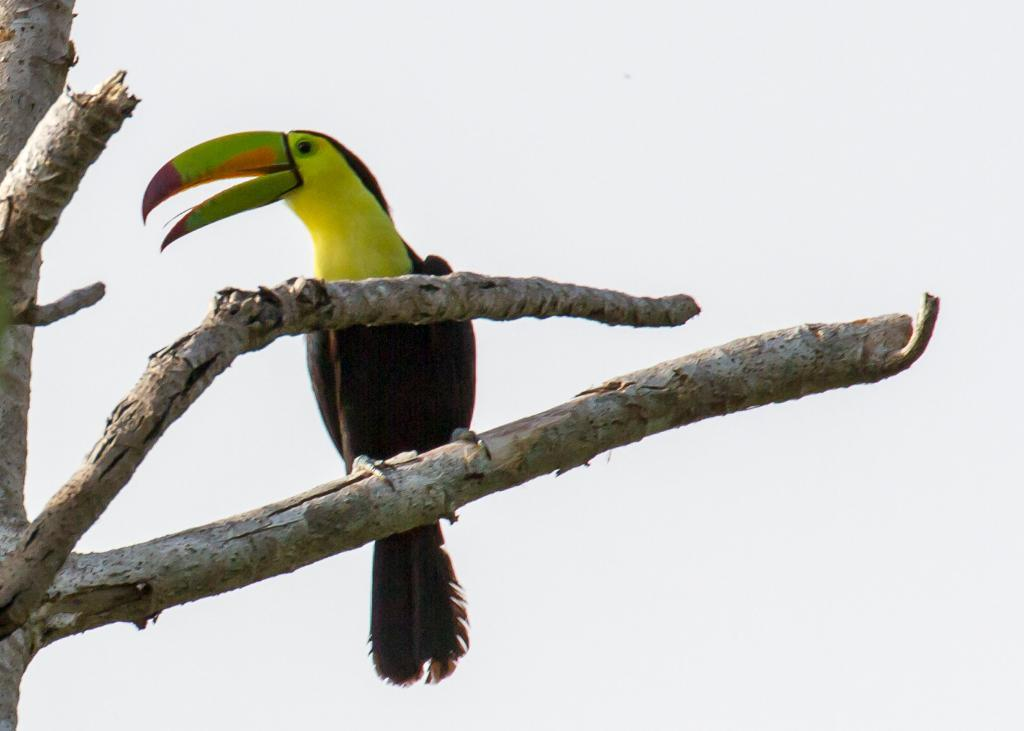What type of animal can be seen in the image? There is a bird in the image. Where is the bird located? The bird is sitting on the branch of a tree. What type of sail can be seen on the bird in the image? There is no sail present on the bird in the image. 